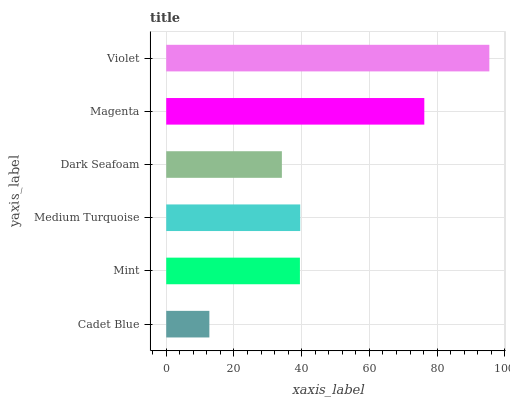Is Cadet Blue the minimum?
Answer yes or no. Yes. Is Violet the maximum?
Answer yes or no. Yes. Is Mint the minimum?
Answer yes or no. No. Is Mint the maximum?
Answer yes or no. No. Is Mint greater than Cadet Blue?
Answer yes or no. Yes. Is Cadet Blue less than Mint?
Answer yes or no. Yes. Is Cadet Blue greater than Mint?
Answer yes or no. No. Is Mint less than Cadet Blue?
Answer yes or no. No. Is Medium Turquoise the high median?
Answer yes or no. Yes. Is Mint the low median?
Answer yes or no. Yes. Is Mint the high median?
Answer yes or no. No. Is Cadet Blue the low median?
Answer yes or no. No. 